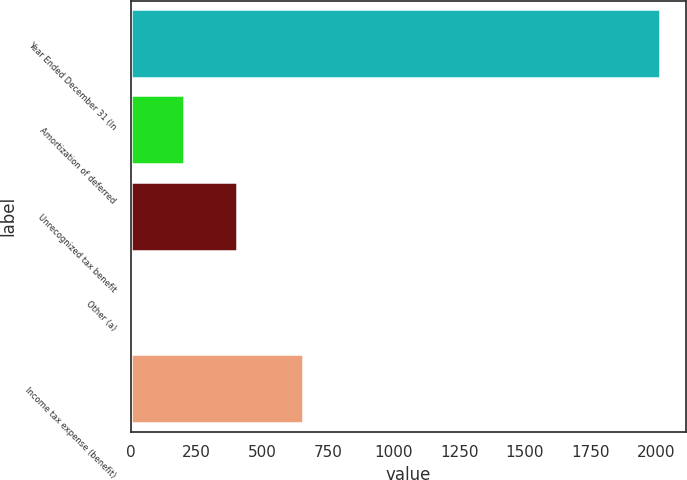Convert chart to OTSL. <chart><loc_0><loc_0><loc_500><loc_500><bar_chart><fcel>Year Ended December 31 (In<fcel>Amortization of deferred<fcel>Unrecognized tax benefit<fcel>Other (a)<fcel>Income tax expense (benefit)<nl><fcel>2013<fcel>204<fcel>405<fcel>3<fcel>656<nl></chart> 